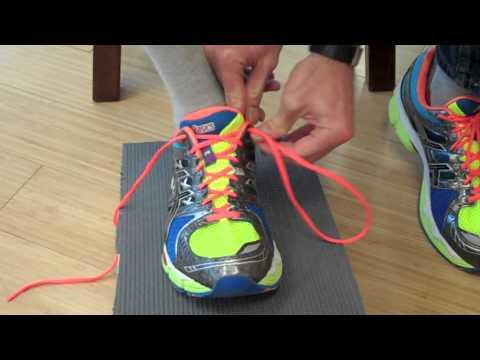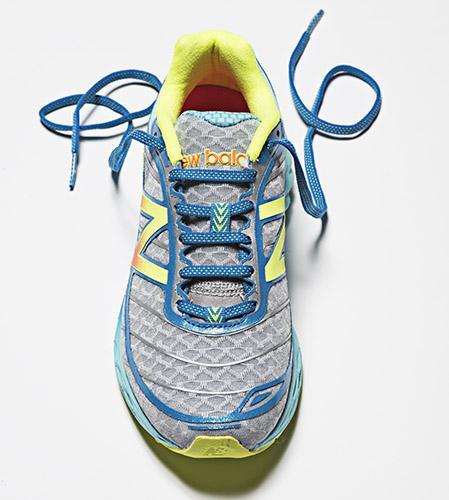The first image is the image on the left, the second image is the image on the right. For the images displayed, is the sentence "There is a total of four shoes." factually correct? Answer yes or no. No. The first image is the image on the left, the second image is the image on the right. Analyze the images presented: Is the assertion "All of the shoes shown have the same color laces." valid? Answer yes or no. No. 